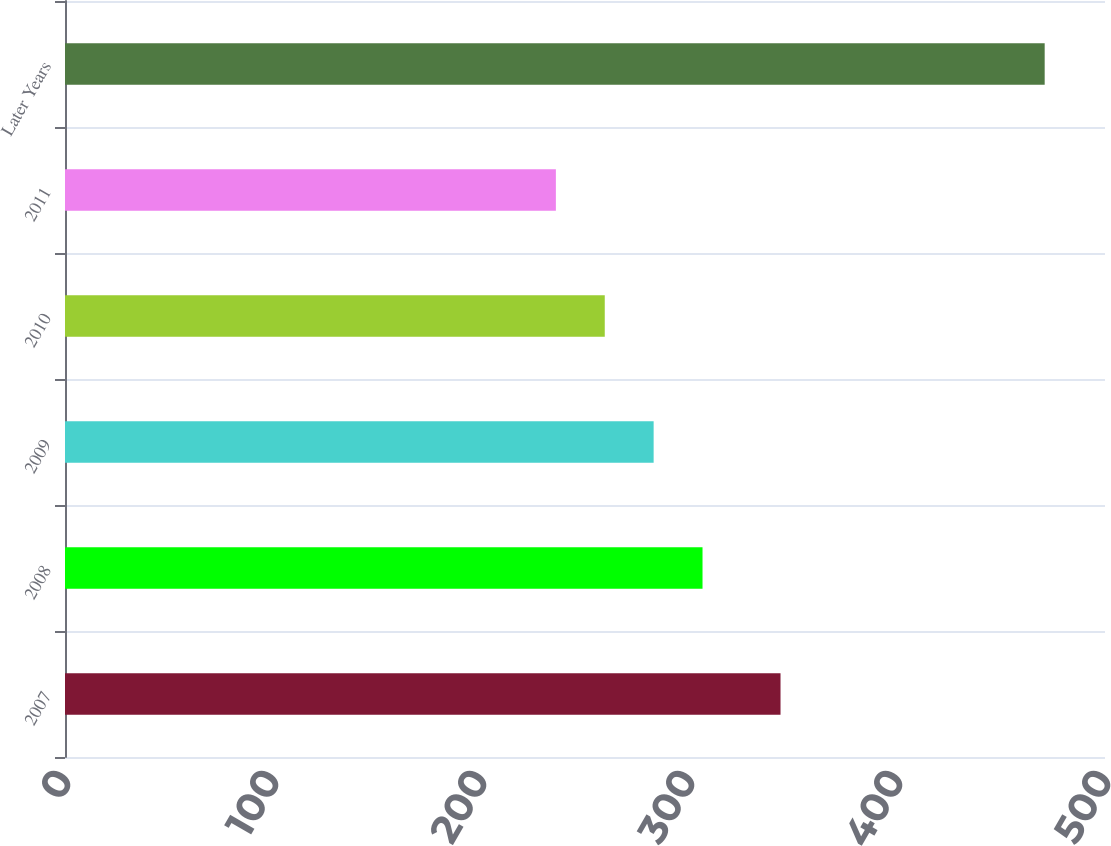Convert chart. <chart><loc_0><loc_0><loc_500><loc_500><bar_chart><fcel>2007<fcel>2008<fcel>2009<fcel>2010<fcel>2011<fcel>Later Years<nl><fcel>344<fcel>306.5<fcel>283<fcel>259.5<fcel>236<fcel>471<nl></chart> 